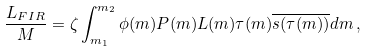Convert formula to latex. <formula><loc_0><loc_0><loc_500><loc_500>\frac { L _ { F I R } } { M } = \zeta \int _ { m _ { 1 } } ^ { m _ { 2 } } \phi ( m ) P ( m ) L ( m ) \tau ( m ) \overline { s ( \tau ( m ) ) } d m \, ,</formula> 